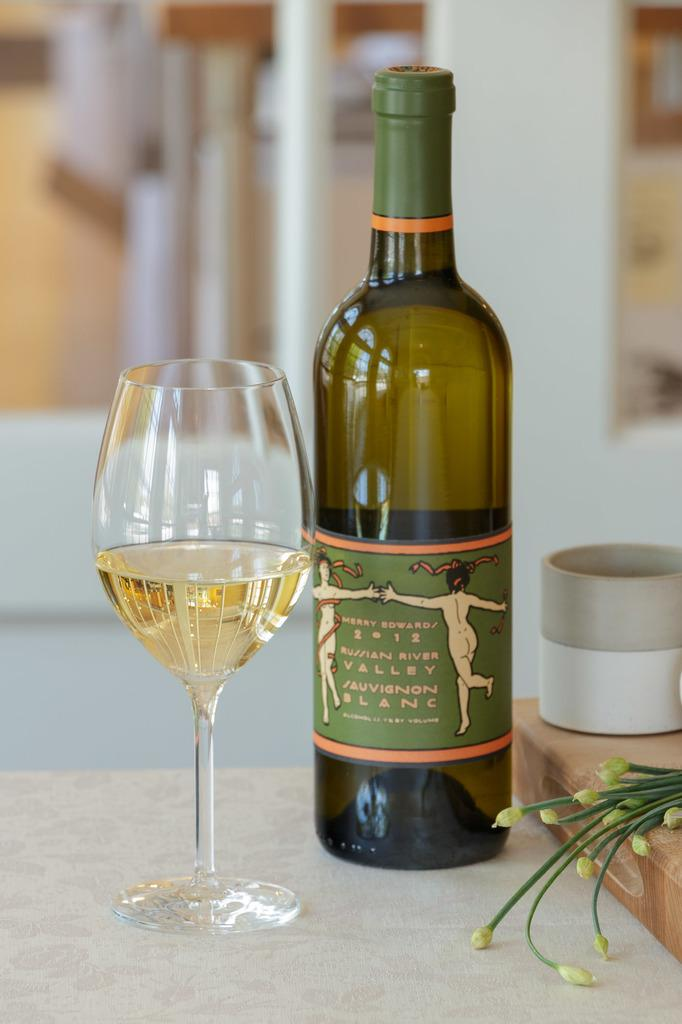<image>
Provide a brief description of the given image. A green bottle with 2012 on the label and a glass of drink beside it. 